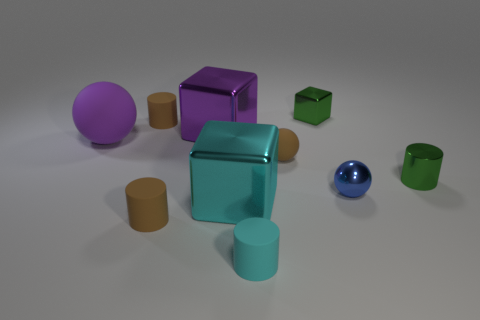Subtract 1 cubes. How many cubes are left? 2 Subtract all cylinders. How many objects are left? 6 Add 2 brown rubber cylinders. How many brown rubber cylinders are left? 4 Add 8 green shiny blocks. How many green shiny blocks exist? 9 Subtract 1 cyan cubes. How many objects are left? 9 Subtract all small purple cylinders. Subtract all tiny blue balls. How many objects are left? 9 